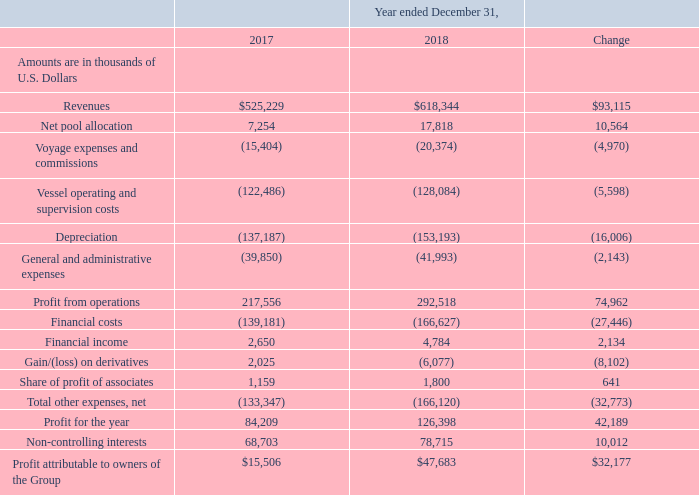Year Ended December 31, 2017 Compared to Year Ended December 31, 2018
During the year ended December 31, 2018, we had an average of 26.0 ships operating in our owned and bareboat fleet (including ships owned by the Partnership), having 9,030 operating days and an average of 25.5 ships operating under our technical management (including 25.0 of our owned and bareboat ships). During the year ended December 31, 2017, we had an average of 23.0 ships operating in our owned and bareboat fleet having 8,317 operating days and an average of 23.4 ships operating under our technical management (including 22.0 of our owned ships).
Revenues: Revenues increased by 17.7%, or $93.1 million, from $525.2 million during the year ended December 31, 2017 to $618.3 million during the year ended December 31, 2018. The increase in revenues is mainly attributable to an increase of $64.2 million in revenues from our vessels operating in the spot market due to the significant increase in LNG shipping spot rates during the year. There was also an increase in revenues of $63.7 million due to the deliveries of the GasLog Houston, the GasLog Hong Kong and the GasLog Genoa (which were delivered on January 8, 2018, March 20, 2018 and March 29, 2018, respectively). These deliveries resulted in an increase in operating days. These increases were partially offset by a decrease of $25.4 million due to the expiration of the initial time charters of the GasLog Shanghai, the GasLog Santiago and the GasLog Sydney. Following the expiration of their initial charters, the GasLog Shanghai has been trading in the spot market through the Cool Pool, the GasLog Santiago began a new, multi-year charter with Trafigura and the GasLog Sydney began a new 18-month charter with Cheniere. There was also a decrease of $8.4 million due to increased off-hire days for four scheduled dry-dockings in the year ended December 31, 2018 compared to only one scheduled dry-docking in the same period of 2017 and a decrease of $0.7 million due to increased off-hire days from the remaining vessels. The average daily hire rate increased from $63,006 for the year ended December 31, 2017 to $68,392 for the year ended December 31, 2018. Furthermore, there was a decrease of $0.3 million in revenues from technical management services mainly due to the decrease in the average number of the managed vessels owned by third parties.
How many ships are operating in 2018 and 2017 on average respectively? 26.0, 23.0. What accounted for the change in revenue? Mainly attributable to an increase of $64.2 million in revenues from our vessels operating in the spot market due to the significant increase in lng shipping spot rates during the year. What was the reason for the increase in operating days? Due to the deliveries of the gaslog houston, the gaslog hong kong and the gaslog genoa. In which year has a higher financial income? 4,784 > 2,650
Answer: 2018. What was the change in average daily hire rate from 2017 to 2018?
Answer scale should be: thousand. $68,392 - $63,006 
Answer: 5386. What was the percentage change in profit from 2017 to 2018?
Answer scale should be: percent. (126,398 - 84,209)/84,209 
Answer: 50.1. 